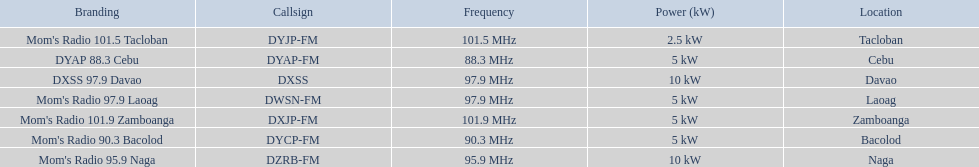What are all of the frequencies? 97.9 MHz, 95.9 MHz, 90.3 MHz, 88.3 MHz, 101.5 MHz, 101.9 MHz, 97.9 MHz. Which of these frequencies is the lowest? 88.3 MHz. Which branding does this frequency belong to? DYAP 88.3 Cebu. 